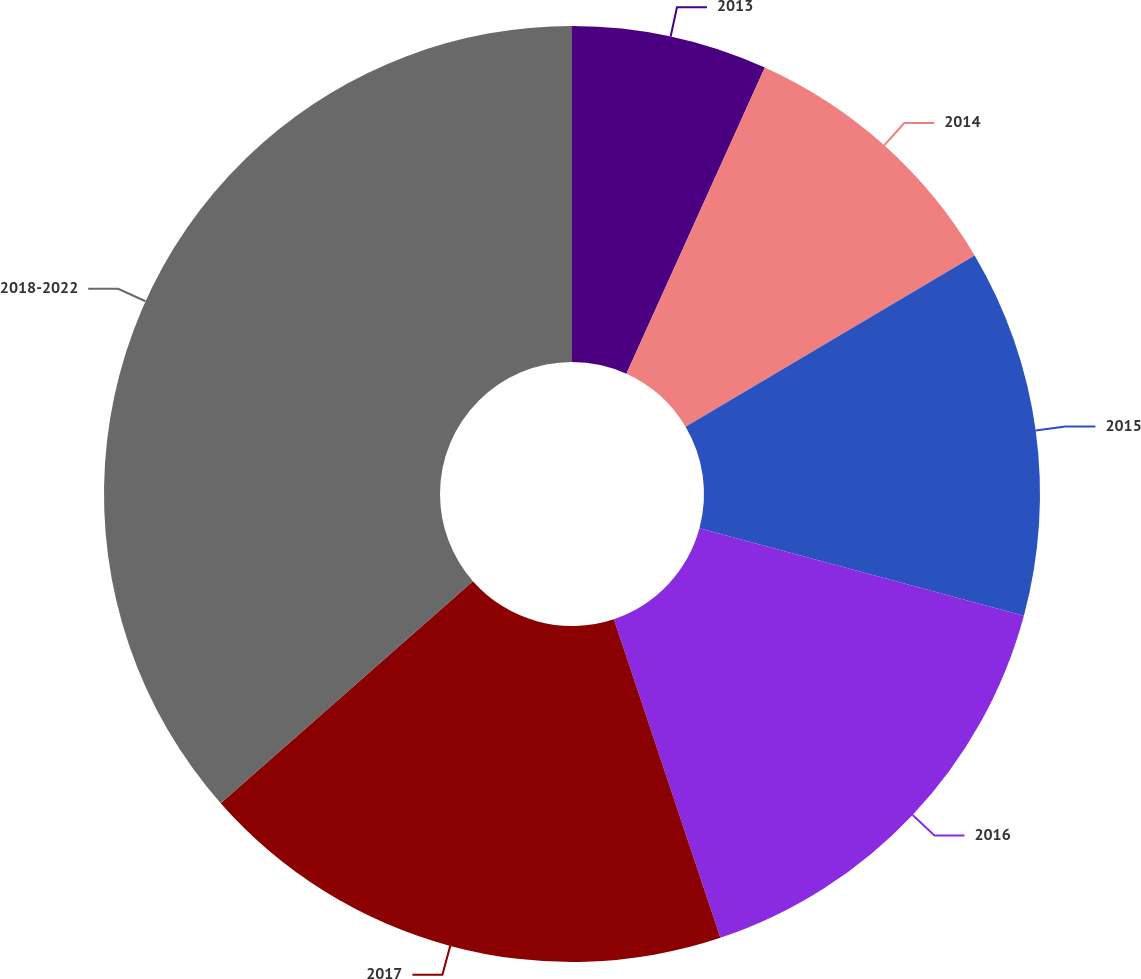Convert chart to OTSL. <chart><loc_0><loc_0><loc_500><loc_500><pie_chart><fcel>2013<fcel>2014<fcel>2015<fcel>2016<fcel>2017<fcel>2018-2022<nl><fcel>6.76%<fcel>9.73%<fcel>12.7%<fcel>15.68%<fcel>18.65%<fcel>36.49%<nl></chart> 